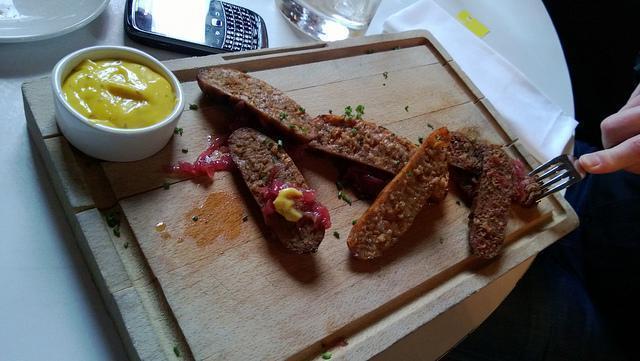How many hot dogs are in the photo?
Give a very brief answer. 2. How many people can be seen?
Give a very brief answer. 1. How many bears are in the picture?
Give a very brief answer. 0. 